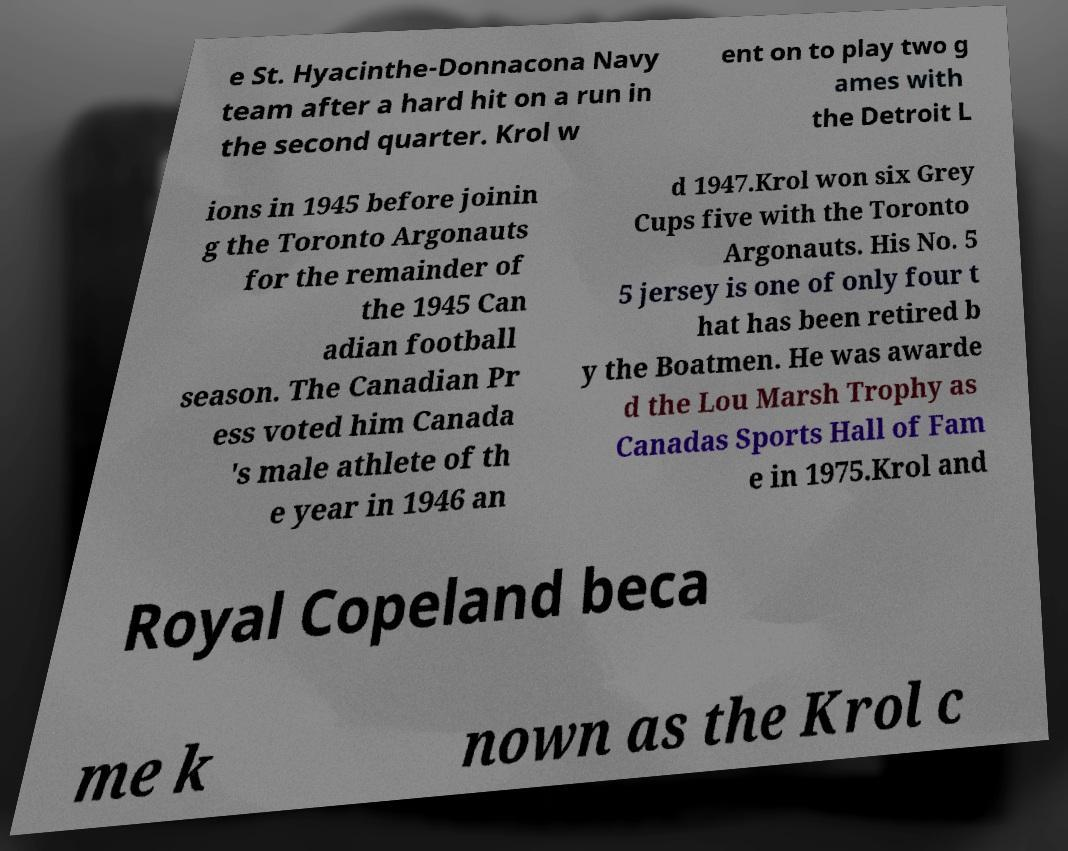What messages or text are displayed in this image? I need them in a readable, typed format. e St. Hyacinthe-Donnacona Navy team after a hard hit on a run in the second quarter. Krol w ent on to play two g ames with the Detroit L ions in 1945 before joinin g the Toronto Argonauts for the remainder of the 1945 Can adian football season. The Canadian Pr ess voted him Canada 's male athlete of th e year in 1946 an d 1947.Krol won six Grey Cups five with the Toronto Argonauts. His No. 5 5 jersey is one of only four t hat has been retired b y the Boatmen. He was awarde d the Lou Marsh Trophy as Canadas Sports Hall of Fam e in 1975.Krol and Royal Copeland beca me k nown as the Krol c 